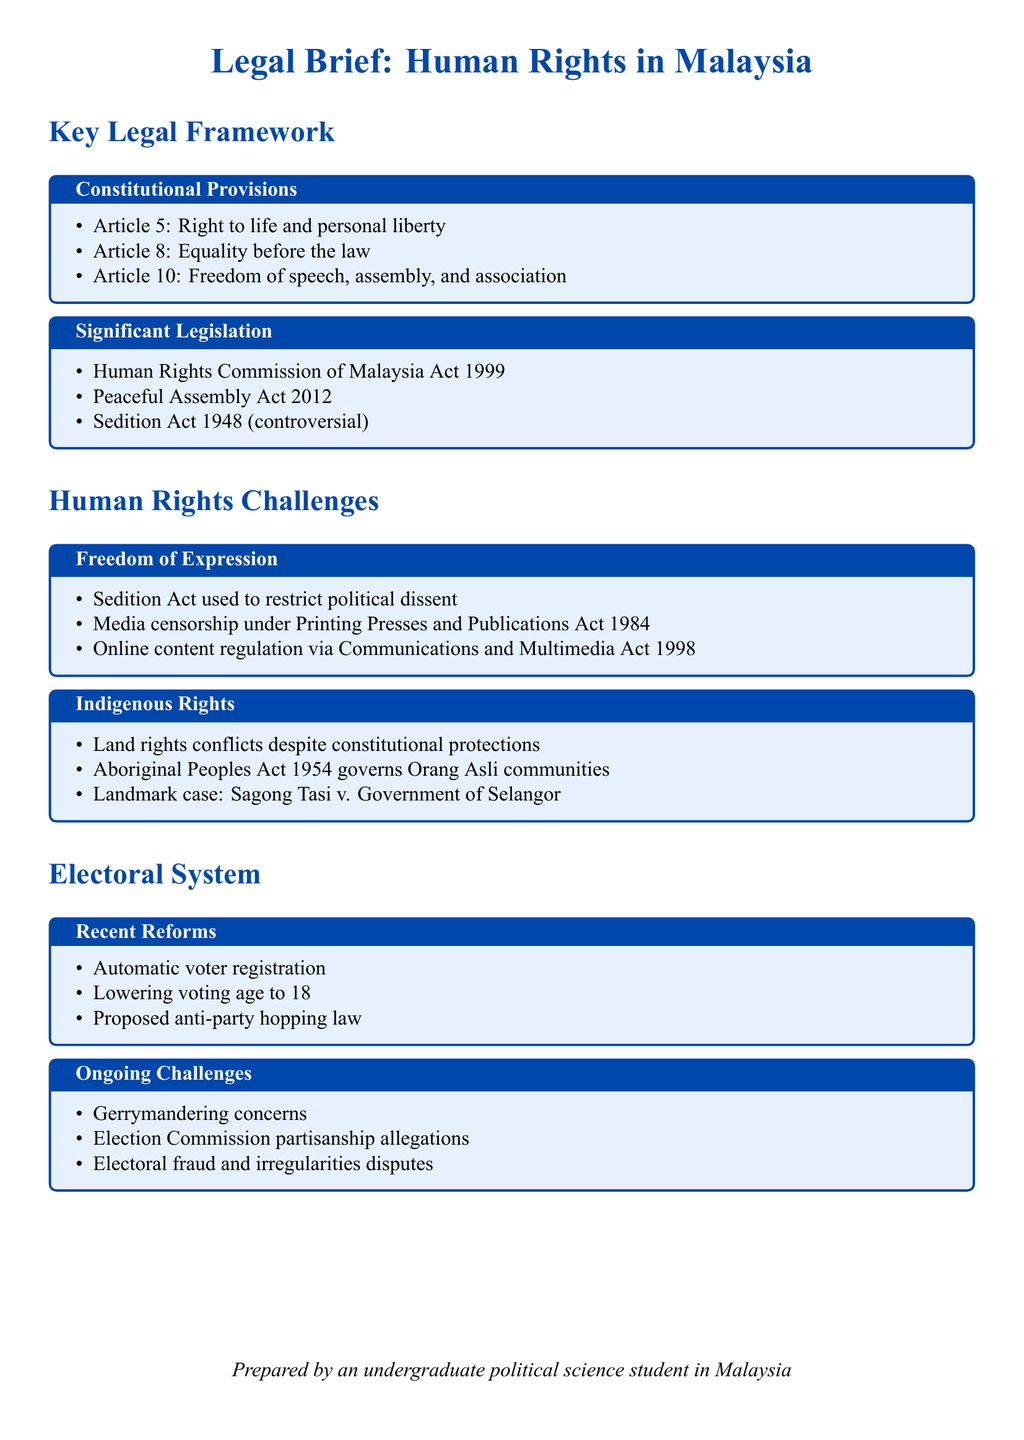What are the three key constitutional provisions related to human rights in Malaysia? The document lists three constitutional provisions relevant to human rights under constitutional provisions, which are Article 5, Article 8, and Article 10.
Answer: Article 5, Article 8, Article 10 What is the purpose of the Human Rights Commission of Malaysia Act 1999? This Act is categorized under significant legislation which aims to promote and protect human rights in Malaysia.
Answer: Promote and protect human rights Which act is considered controversial regarding freedom of expression? The document names the Sedition Act 1948 as a significant legislation which is controversial due to its implications for freedom of political dissent.
Answer: Sedition Act 1948 What percentage of voting age has been lowered to in recent reforms? The document states the voting age has been lowered to 18 as part of recent electoral reforms.
Answer: 18 What is the landmark case related to indigenous rights mentioned in the document? The document references the case "Sagong Tasi v. Government of Selangor" in the context of indigenous rights in Malaysia.
Answer: Sagong Tasi v. Government of Selangor What is a major ongoing challenge facing Malaysia's electoral system? The document identifies several ongoing challenges, including gerrymandering concerns, which affect the fairness of elections.
Answer: Gerrymandering concerns What does the term 'electoral fraud' refer to in the context of this document? Electoral fraud is mentioned as a type of ongoing challenge related to disputes in the electoral system, affecting integrity and democratic processes.
Answer: Disputes over electoral integrity What does the term 'censorship' refer to in this legal brief? Censorship is discussed under human rights challenges, particularly in terms of media laws that restrict freedom of speech and expression.
Answer: Media laws restrict freedom of speech What is the focus of the section titled "Electoral System"? The section titled "Electoral System" focuses on recent reforms and ongoing challenges within Malaysia’s electoral framework.
Answer: Recent reforms and ongoing challenges 